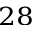<formula> <loc_0><loc_0><loc_500><loc_500>^ { 2 8 }</formula> 